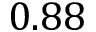<formula> <loc_0><loc_0><loc_500><loc_500>0 . 8 8</formula> 